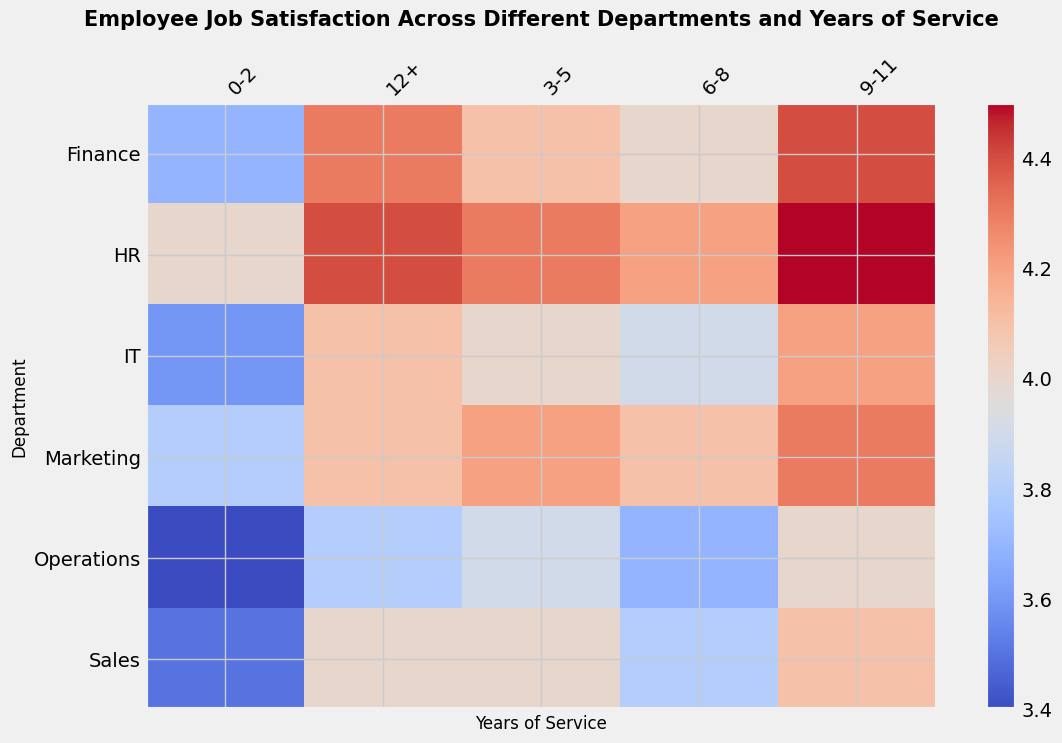What department has the highest job satisfaction for employees with 9-11 years of service? To find the department with the highest job satisfaction for employees with 9-11 years of service, look across the row labeled "9-11" in the heatmap. Identify the highest value. HR has the highest value of 4.5.
Answer: HR Which department has the lowest job satisfaction for employees with 0-2 years of service? Look at the "0-2" column and identify the department with the lowest job satisfaction value. The value for Operations (3.4) is the lowest.
Answer: Operations Calculate the average job satisfaction for the IT department across all years of service. Find all job satisfaction values for the IT department (3.6, 4.0, 3.9, 4.2, 4.1), sum them up (3.6 + 4.0 + 3.9 + 4.2 + 4.1 = 19.8), and divide by the number of values (5). The average is 19.8 / 5 = 3.96.
Answer: 3.96 Compare the job satisfaction between HR and Sales for employees with 12+ years of service. Which is higher? First, find the values for HR and Sales for employees with 12+ years of service (HR: 4.4, Sales: 4.0). HR's job satisfaction is higher because 4.4 > 4.0.
Answer: HR Which department shows the greatest increase in job satisfaction from 0-2 years to 9-11 years of service? Calculate the difference in job satisfaction from 0-2 years to 9-11 years for each department:
Sales: (4.1 - 3.5 = 0.6), 
Marketing: (4.3 - 3.8 = 0.5), 
Finance: (4.4 - 3.7 = 0.7), 
HR: (4.5 - 4.0 = 0.5), 
IT: (4.2 - 3.6 = 0.6), 
Operations: (4.0 - 3.4 = 0.6). Finance has the greatest increase of 0.7.
Answer: Finance Which group shows more consistent job satisfaction over the years—IT or Operations? Review the job satisfaction values for IT (3.6, 4.0, 3.9, 4.2, 4.1) and Operations (3.4, 3.9, 3.7, 4.0, 3.8). IT's values have less deviation. Consistency is indicated by smaller differences between values. Operations has more fluctuation.
Answer: IT What is the overall job satisfaction trend for the Marketing department as years of service increase? Observe the values for Marketing from 0-2 to 12+ years of service (3.8, 4.2, 4.1, 4.3, 4.1). Marketing has a generally increasing trend with a slight dip before plateauing.
Answer: Increasing with minor fluctuations How does job satisfaction in the Finance department compare to the Sales department for 6-8 years of service? Compare the job satisfaction values for Finance (4.0) and Sales (3.8) in the 6-8 years of service column. Finance has a higher job satisfaction value (4.0 > 3.8).
Answer: Finance Summarize the job satisfaction pattern for the Operations department. Look at the job satisfaction values for Operations (3.4, 3.9, 3.7, 4.0, 3.8). Job satisfaction starts low, increases, dips slightly, peaks again, and then drops slightly.
Answer: Starts low, increases, dips, peaks, drops slightly 